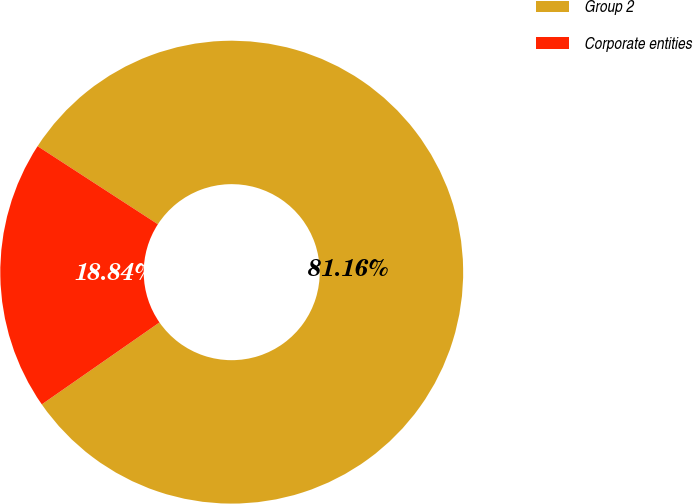<chart> <loc_0><loc_0><loc_500><loc_500><pie_chart><fcel>Group 2<fcel>Corporate entities<nl><fcel>81.16%<fcel>18.84%<nl></chart> 